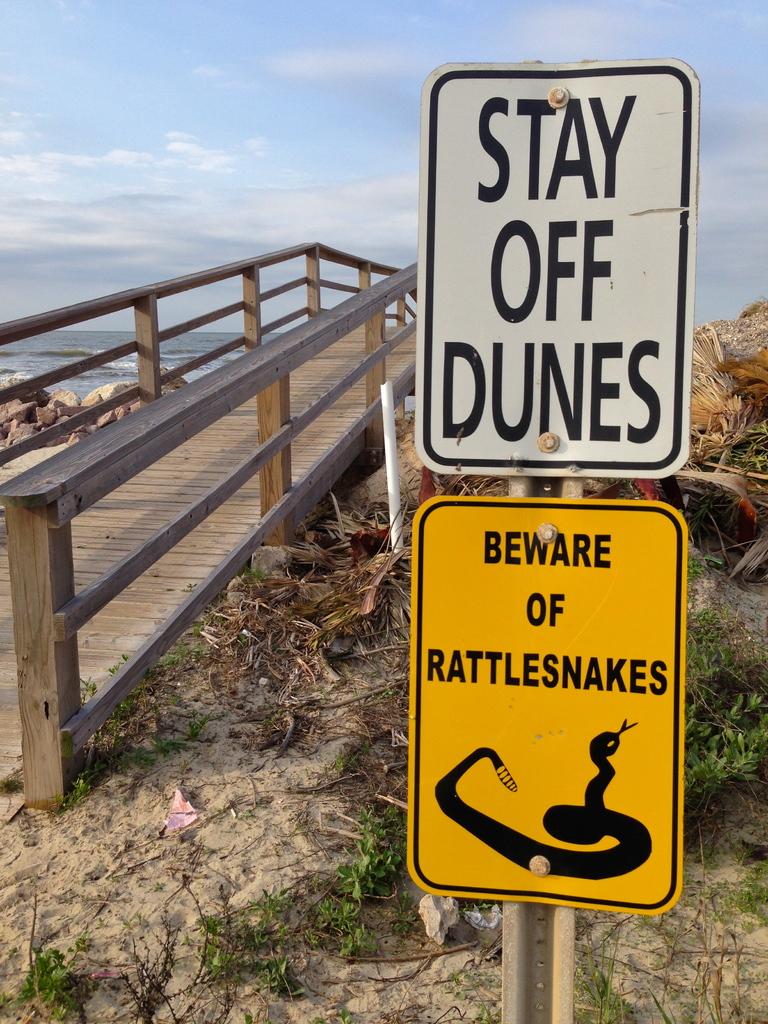What should you do with the dunes?
Your answer should be compact. Stay off. 